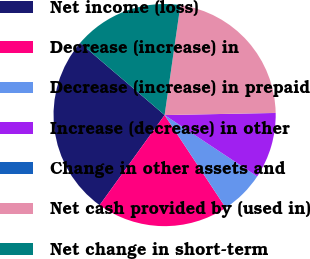Convert chart to OTSL. <chart><loc_0><loc_0><loc_500><loc_500><pie_chart><fcel>Net income (loss)<fcel>Decrease (increase) in<fcel>Decrease (increase) in prepaid<fcel>Increase (decrease) in other<fcel>Change in other assets and<fcel>Net cash provided by (used in)<fcel>Net change in short-term<nl><fcel>26.3%<fcel>19.22%<fcel>6.41%<fcel>9.61%<fcel>0.01%<fcel>22.42%<fcel>16.02%<nl></chart> 